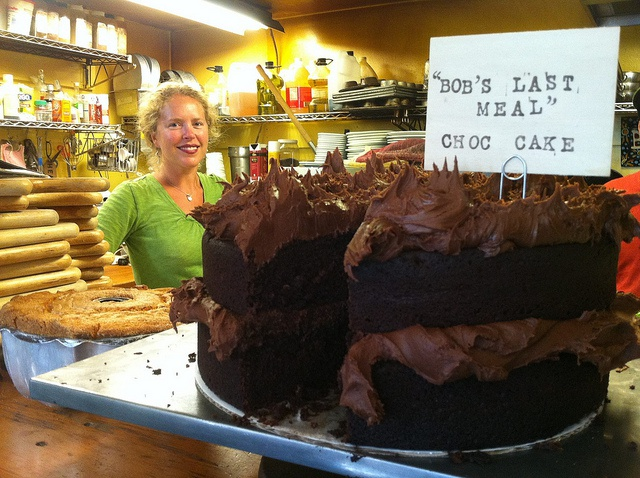Describe the objects in this image and their specific colors. I can see cake in tan, black, maroon, and gray tones, people in tan, orange, darkgreen, and olive tones, cake in tan, orange, brown, and gold tones, cake in tan, black, maroon, and brown tones, and hot dog in tan, khaki, and olive tones in this image. 